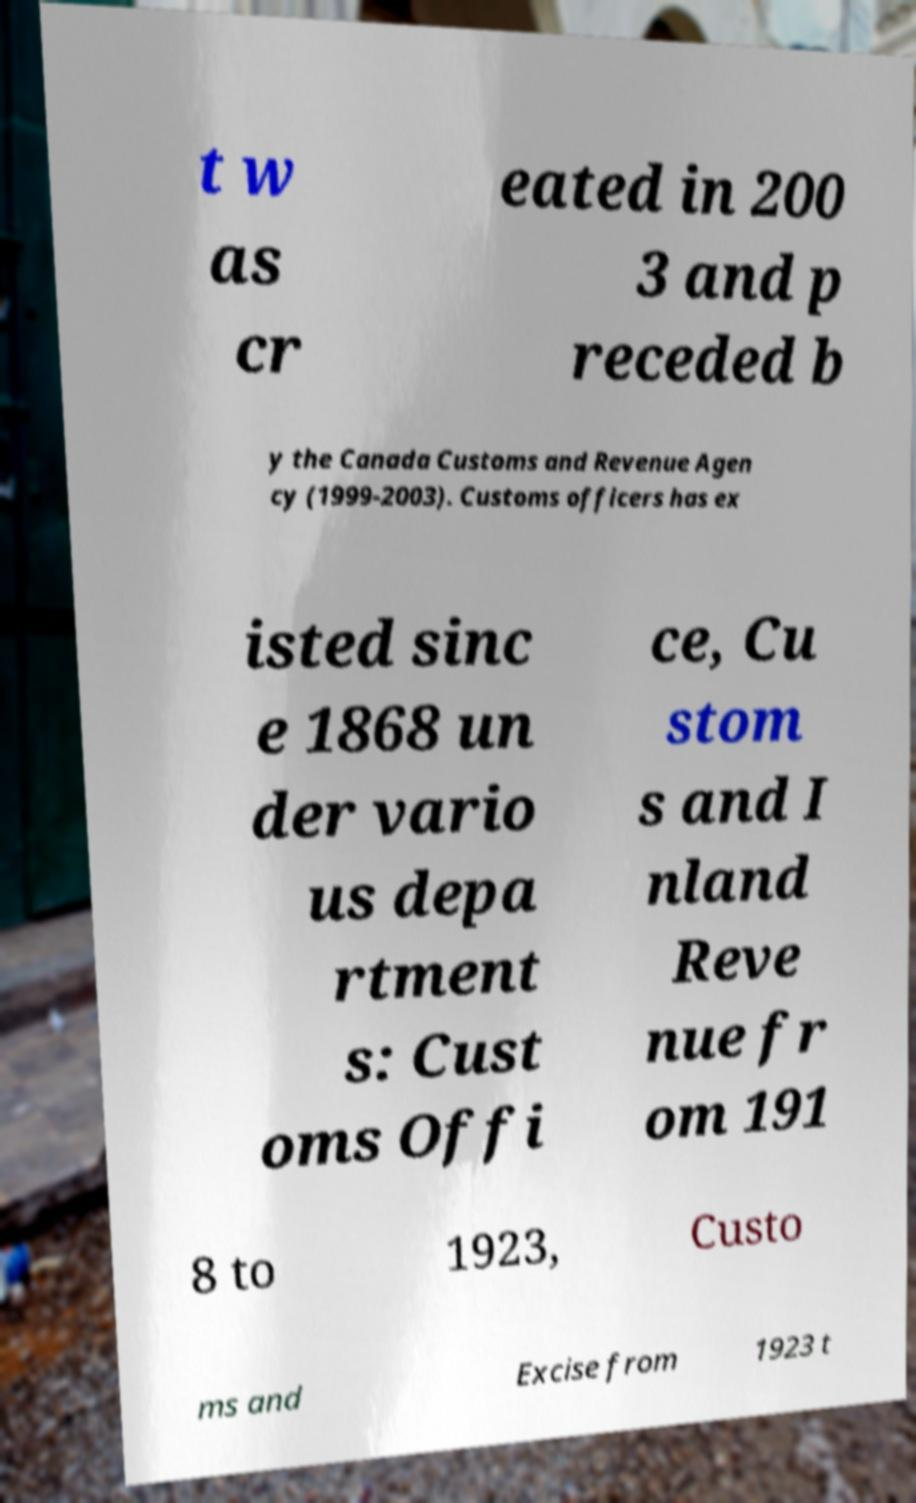I need the written content from this picture converted into text. Can you do that? t w as cr eated in 200 3 and p receded b y the Canada Customs and Revenue Agen cy (1999-2003). Customs officers has ex isted sinc e 1868 un der vario us depa rtment s: Cust oms Offi ce, Cu stom s and I nland Reve nue fr om 191 8 to 1923, Custo ms and Excise from 1923 t 